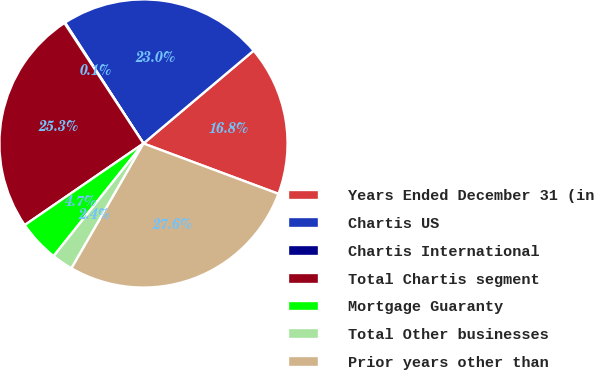<chart> <loc_0><loc_0><loc_500><loc_500><pie_chart><fcel>Years Ended December 31 (in<fcel>Chartis US<fcel>Chartis International<fcel>Total Chartis segment<fcel>Mortgage Guaranty<fcel>Total Other businesses<fcel>Prior years other than<nl><fcel>16.83%<fcel>23.02%<fcel>0.08%<fcel>25.34%<fcel>4.7%<fcel>2.39%<fcel>27.65%<nl></chart> 